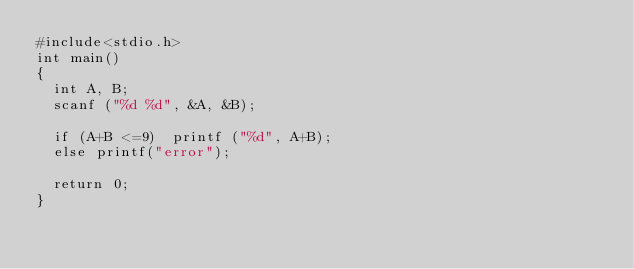<code> <loc_0><loc_0><loc_500><loc_500><_C_>#include<stdio.h>
int main()
{
	int A, B;
	scanf ("%d %d", &A, &B);
	
	if (A+B <=9)	printf ("%d", A+B);
	else printf("error");
	
	return 0;
}</code> 